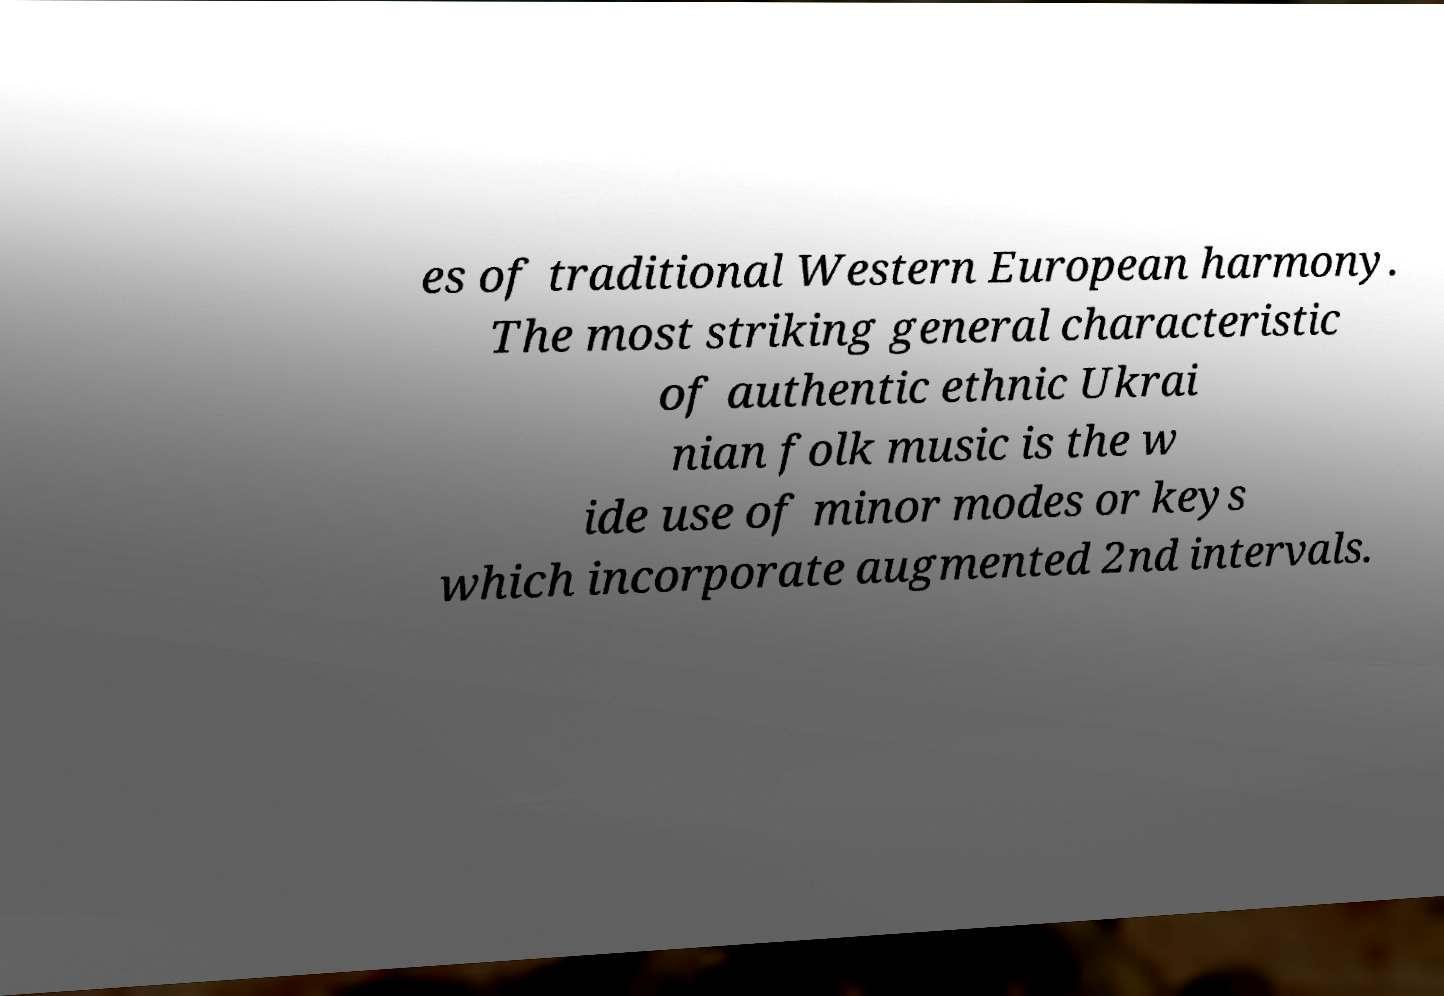I need the written content from this picture converted into text. Can you do that? es of traditional Western European harmony. The most striking general characteristic of authentic ethnic Ukrai nian folk music is the w ide use of minor modes or keys which incorporate augmented 2nd intervals. 